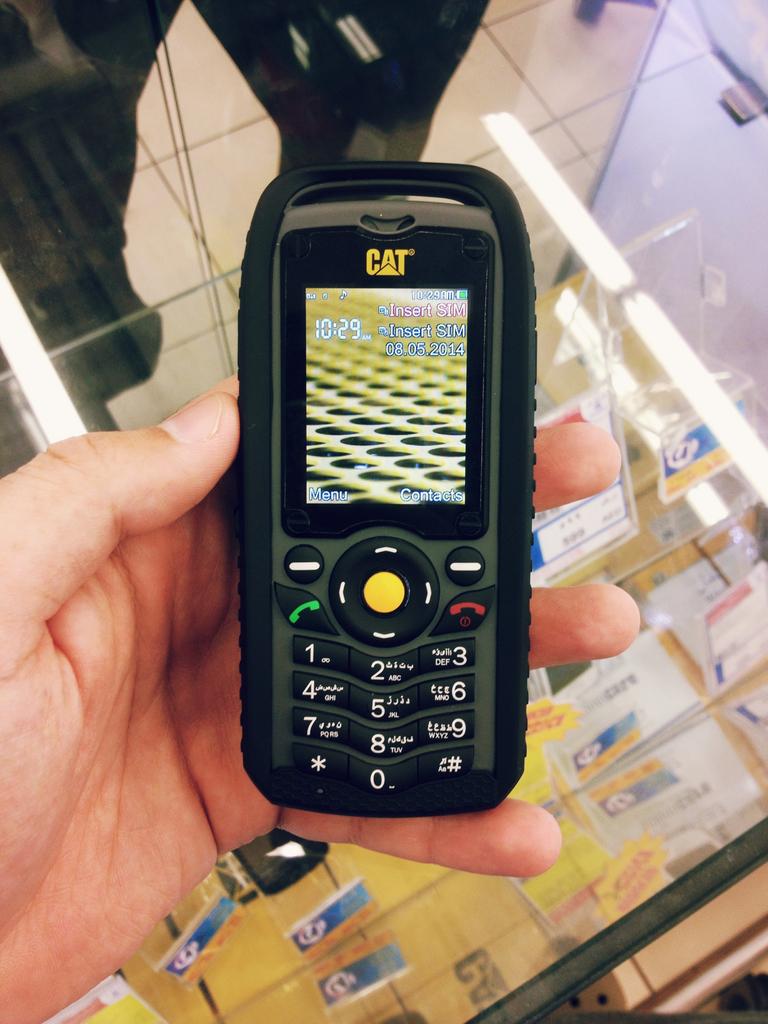What brand is the device?
Make the answer very short. Cat. What time does the device display?
Ensure brevity in your answer.  10:29. 